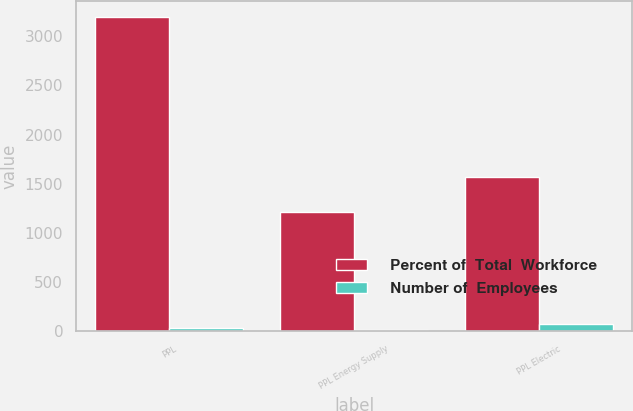Convert chart to OTSL. <chart><loc_0><loc_0><loc_500><loc_500><stacked_bar_chart><ecel><fcel>PPL<fcel>PPL Energy Supply<fcel>PPL Electric<nl><fcel>Percent of  Total  Workforce<fcel>3200<fcel>1210<fcel>1570<nl><fcel>Number of  Employees<fcel>31<fcel>17<fcel>72<nl></chart> 